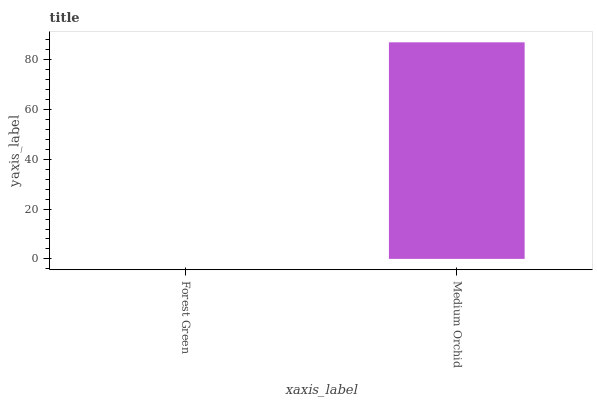Is Forest Green the minimum?
Answer yes or no. Yes. Is Medium Orchid the maximum?
Answer yes or no. Yes. Is Medium Orchid the minimum?
Answer yes or no. No. Is Medium Orchid greater than Forest Green?
Answer yes or no. Yes. Is Forest Green less than Medium Orchid?
Answer yes or no. Yes. Is Forest Green greater than Medium Orchid?
Answer yes or no. No. Is Medium Orchid less than Forest Green?
Answer yes or no. No. Is Medium Orchid the high median?
Answer yes or no. Yes. Is Forest Green the low median?
Answer yes or no. Yes. Is Forest Green the high median?
Answer yes or no. No. Is Medium Orchid the low median?
Answer yes or no. No. 